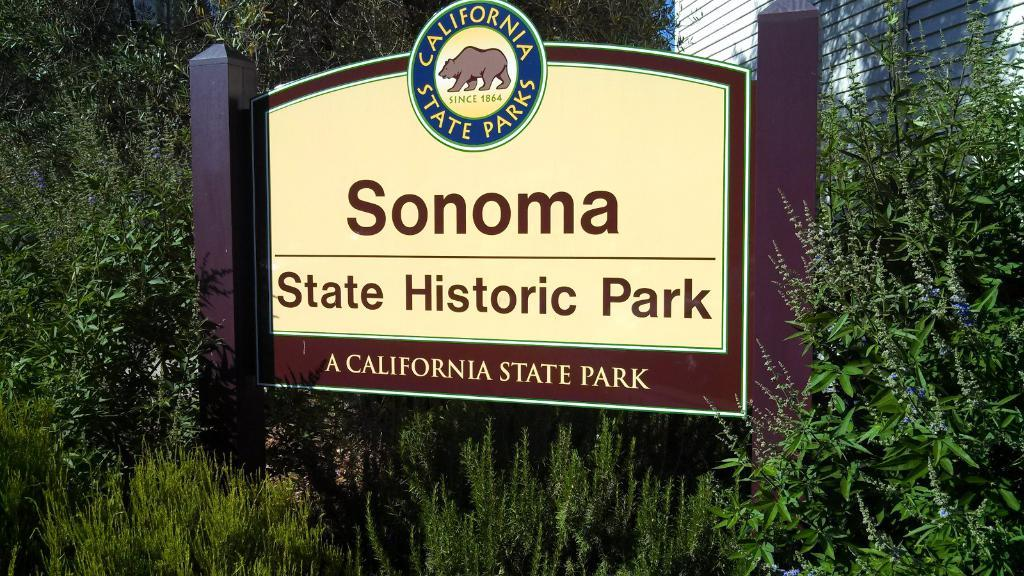What is the main structure in the image? There is a board with poles in the image. What can be seen behind the board? There are trees behind the board. What else is visible in the background of the image? There is a wall visible in the background. What part of the natural environment is visible in the image? The sky is visible in the image. Where is the heart-shaped kettle in the image? There is no heart-shaped kettle present in the image. Can you see a crow perched on the board in the image? There is no crow visible in the image. 